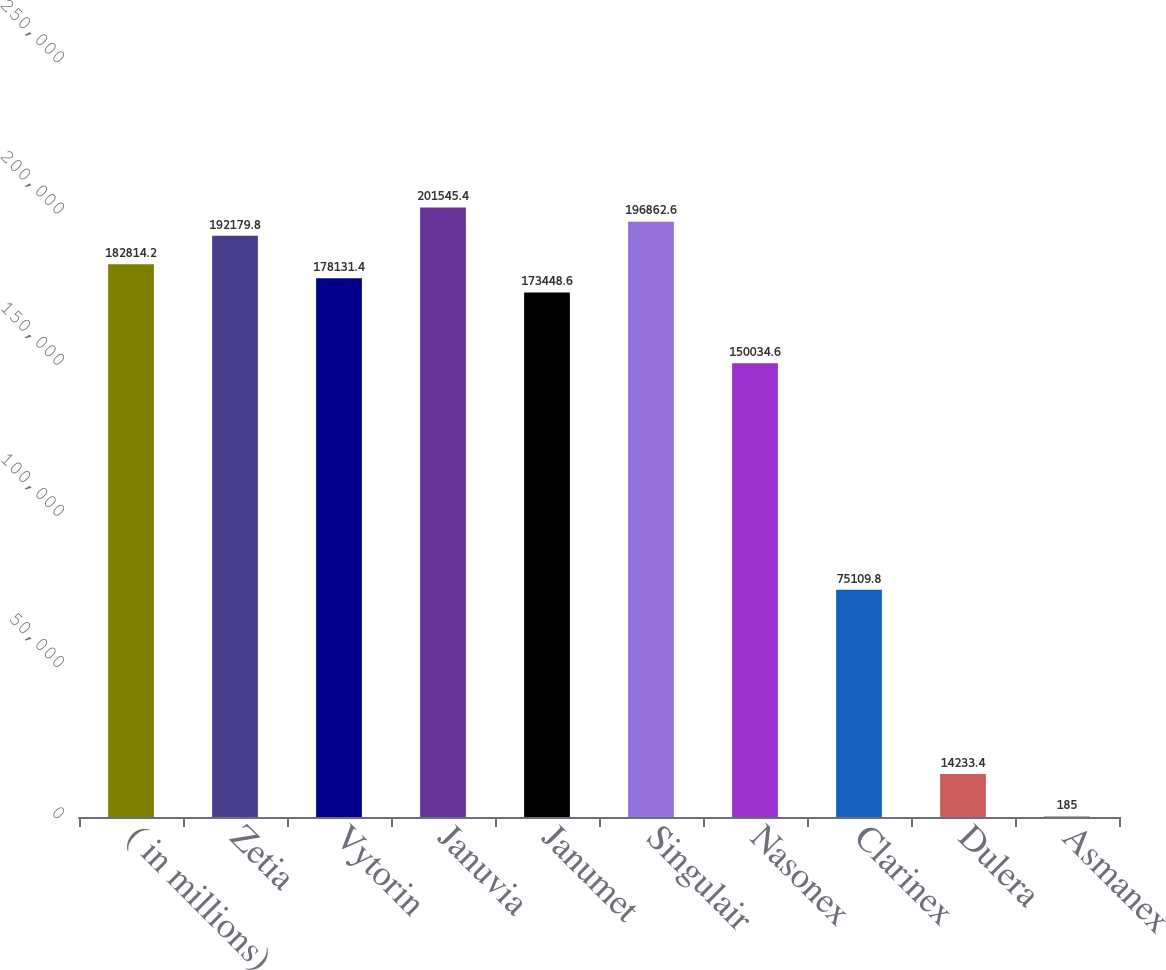<chart> <loc_0><loc_0><loc_500><loc_500><bar_chart><fcel>( in millions)<fcel>Zetia<fcel>Vytorin<fcel>Januvia<fcel>Janumet<fcel>Singulair<fcel>Nasonex<fcel>Clarinex<fcel>Dulera<fcel>Asmanex<nl><fcel>182814<fcel>192180<fcel>178131<fcel>201545<fcel>173449<fcel>196863<fcel>150035<fcel>75109.8<fcel>14233.4<fcel>185<nl></chart> 